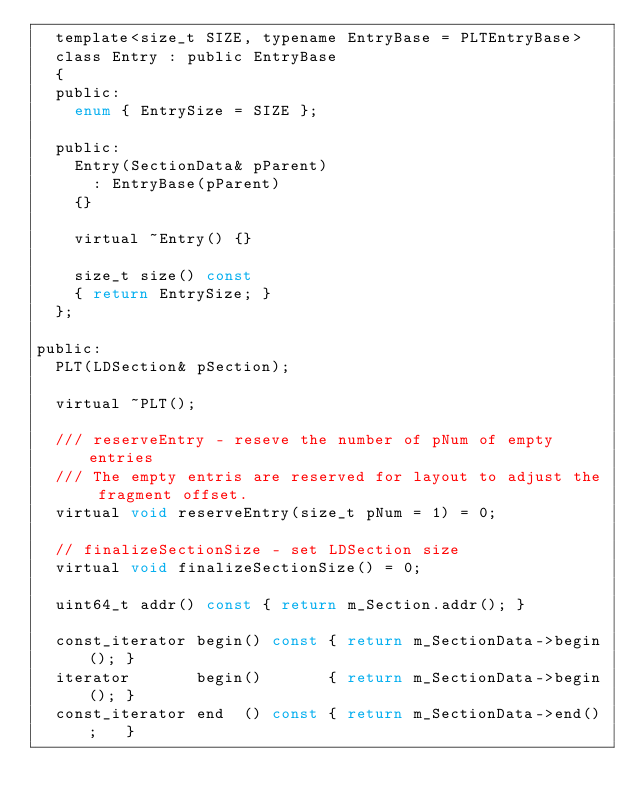<code> <loc_0><loc_0><loc_500><loc_500><_C_>  template<size_t SIZE, typename EntryBase = PLTEntryBase>
  class Entry : public EntryBase
  {
  public:
    enum { EntrySize = SIZE };

  public:
    Entry(SectionData& pParent)
      : EntryBase(pParent)
    {}

    virtual ~Entry() {}

    size_t size() const
    { return EntrySize; }
  };

public:
  PLT(LDSection& pSection);

  virtual ~PLT();

  /// reserveEntry - reseve the number of pNum of empty entries
  /// The empty entris are reserved for layout to adjust the fragment offset.
  virtual void reserveEntry(size_t pNum = 1) = 0;

  // finalizeSectionSize - set LDSection size
  virtual void finalizeSectionSize() = 0;

  uint64_t addr() const { return m_Section.addr(); }

  const_iterator begin() const { return m_SectionData->begin(); }
  iterator       begin()       { return m_SectionData->begin(); }
  const_iterator end  () const { return m_SectionData->end();   }</code> 